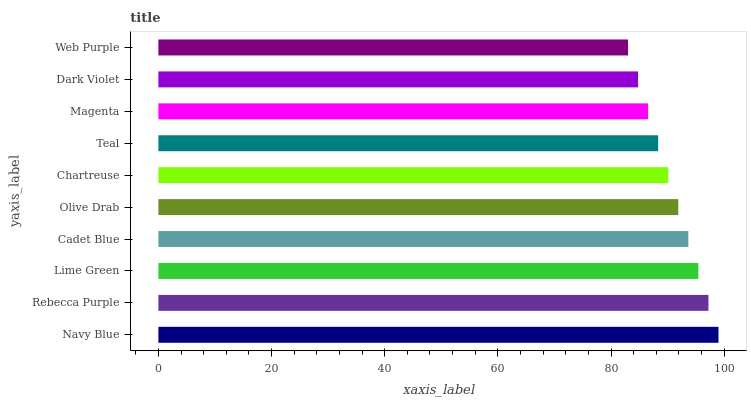Is Web Purple the minimum?
Answer yes or no. Yes. Is Navy Blue the maximum?
Answer yes or no. Yes. Is Rebecca Purple the minimum?
Answer yes or no. No. Is Rebecca Purple the maximum?
Answer yes or no. No. Is Navy Blue greater than Rebecca Purple?
Answer yes or no. Yes. Is Rebecca Purple less than Navy Blue?
Answer yes or no. Yes. Is Rebecca Purple greater than Navy Blue?
Answer yes or no. No. Is Navy Blue less than Rebecca Purple?
Answer yes or no. No. Is Olive Drab the high median?
Answer yes or no. Yes. Is Chartreuse the low median?
Answer yes or no. Yes. Is Lime Green the high median?
Answer yes or no. No. Is Dark Violet the low median?
Answer yes or no. No. 